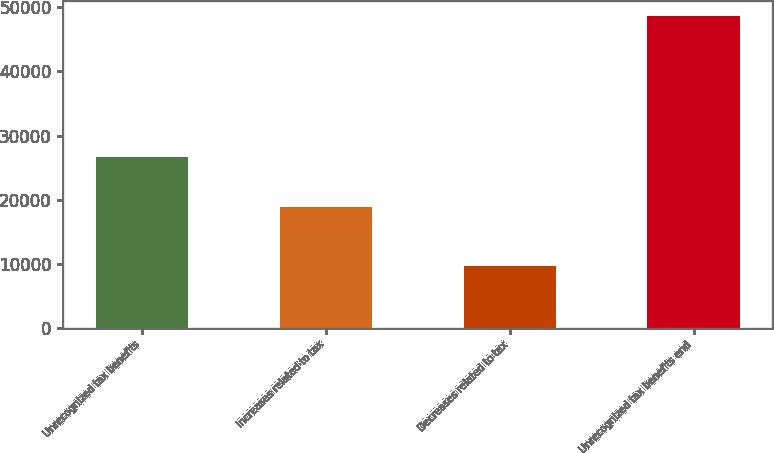<chart> <loc_0><loc_0><loc_500><loc_500><bar_chart><fcel>Unrecognized tax benefits<fcel>Increases related to tax<fcel>Decreases related to tax<fcel>Unrecognized tax benefits end<nl><fcel>26682.8<fcel>18895<fcel>9665<fcel>48604<nl></chart> 